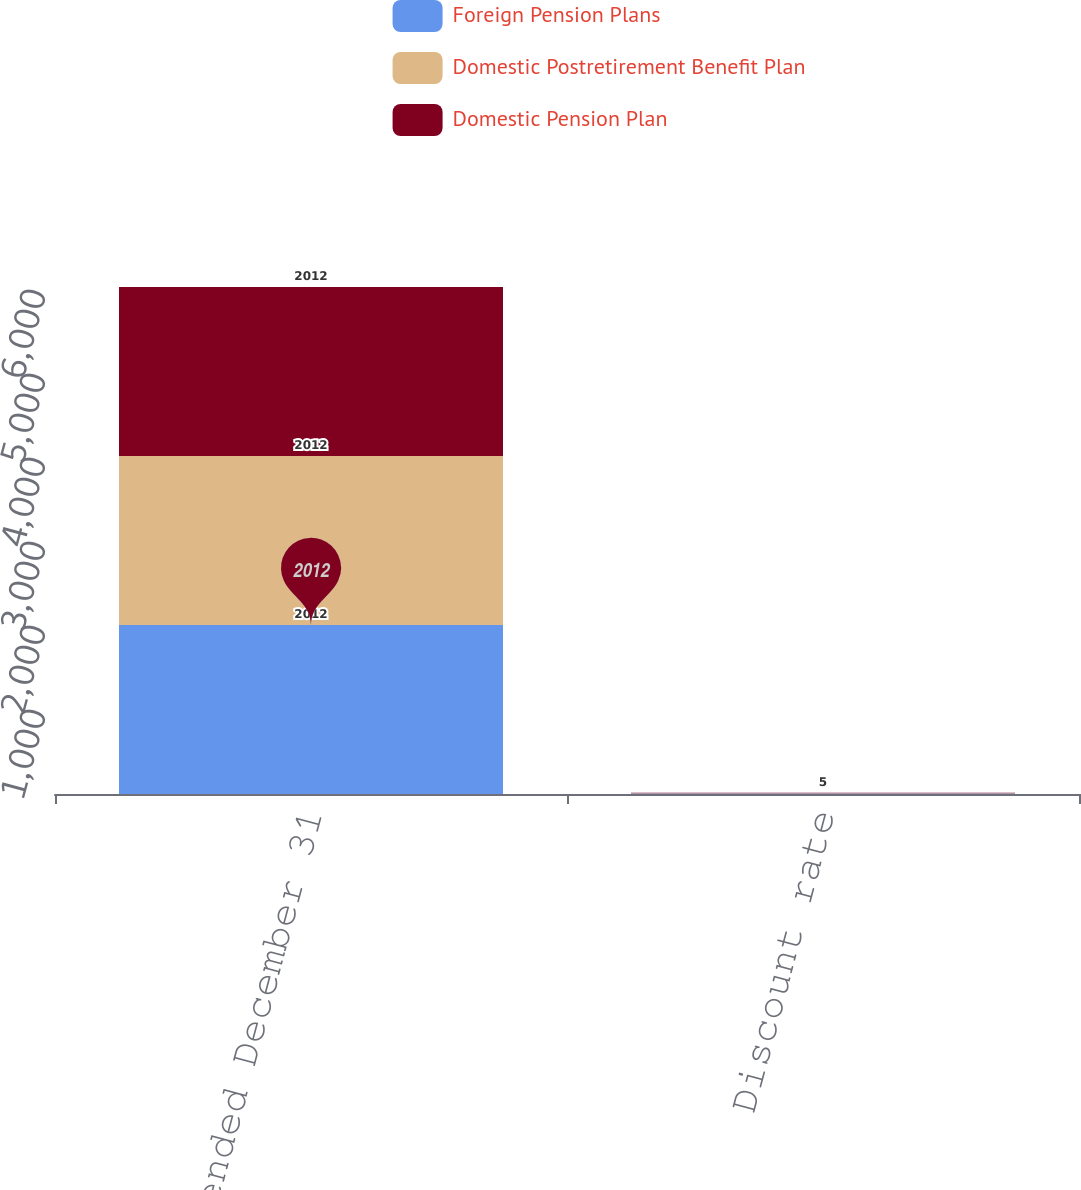Convert chart. <chart><loc_0><loc_0><loc_500><loc_500><stacked_bar_chart><ecel><fcel>Years ended December 31<fcel>Discount rate<nl><fcel>Foreign Pension Plans<fcel>2012<fcel>5<nl><fcel>Domestic Postretirement Benefit Plan<fcel>2012<fcel>5<nl><fcel>Domestic Pension Plan<fcel>2012<fcel>5<nl></chart> 